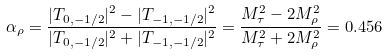Convert formula to latex. <formula><loc_0><loc_0><loc_500><loc_500>\alpha _ { \rho } = \frac { | T _ { 0 , - 1 / 2 } | ^ { 2 } - | T _ { - 1 , - 1 / 2 } | ^ { 2 } } { | T _ { 0 , - 1 / 2 } | ^ { 2 } + | T _ { - 1 , - 1 / 2 } | ^ { 2 } } = \frac { M _ { \tau } ^ { 2 } - 2 M _ { \rho } ^ { 2 } } { M _ { \tau } ^ { 2 } + 2 M _ { \rho } ^ { 2 } } = 0 . 4 5 6</formula> 